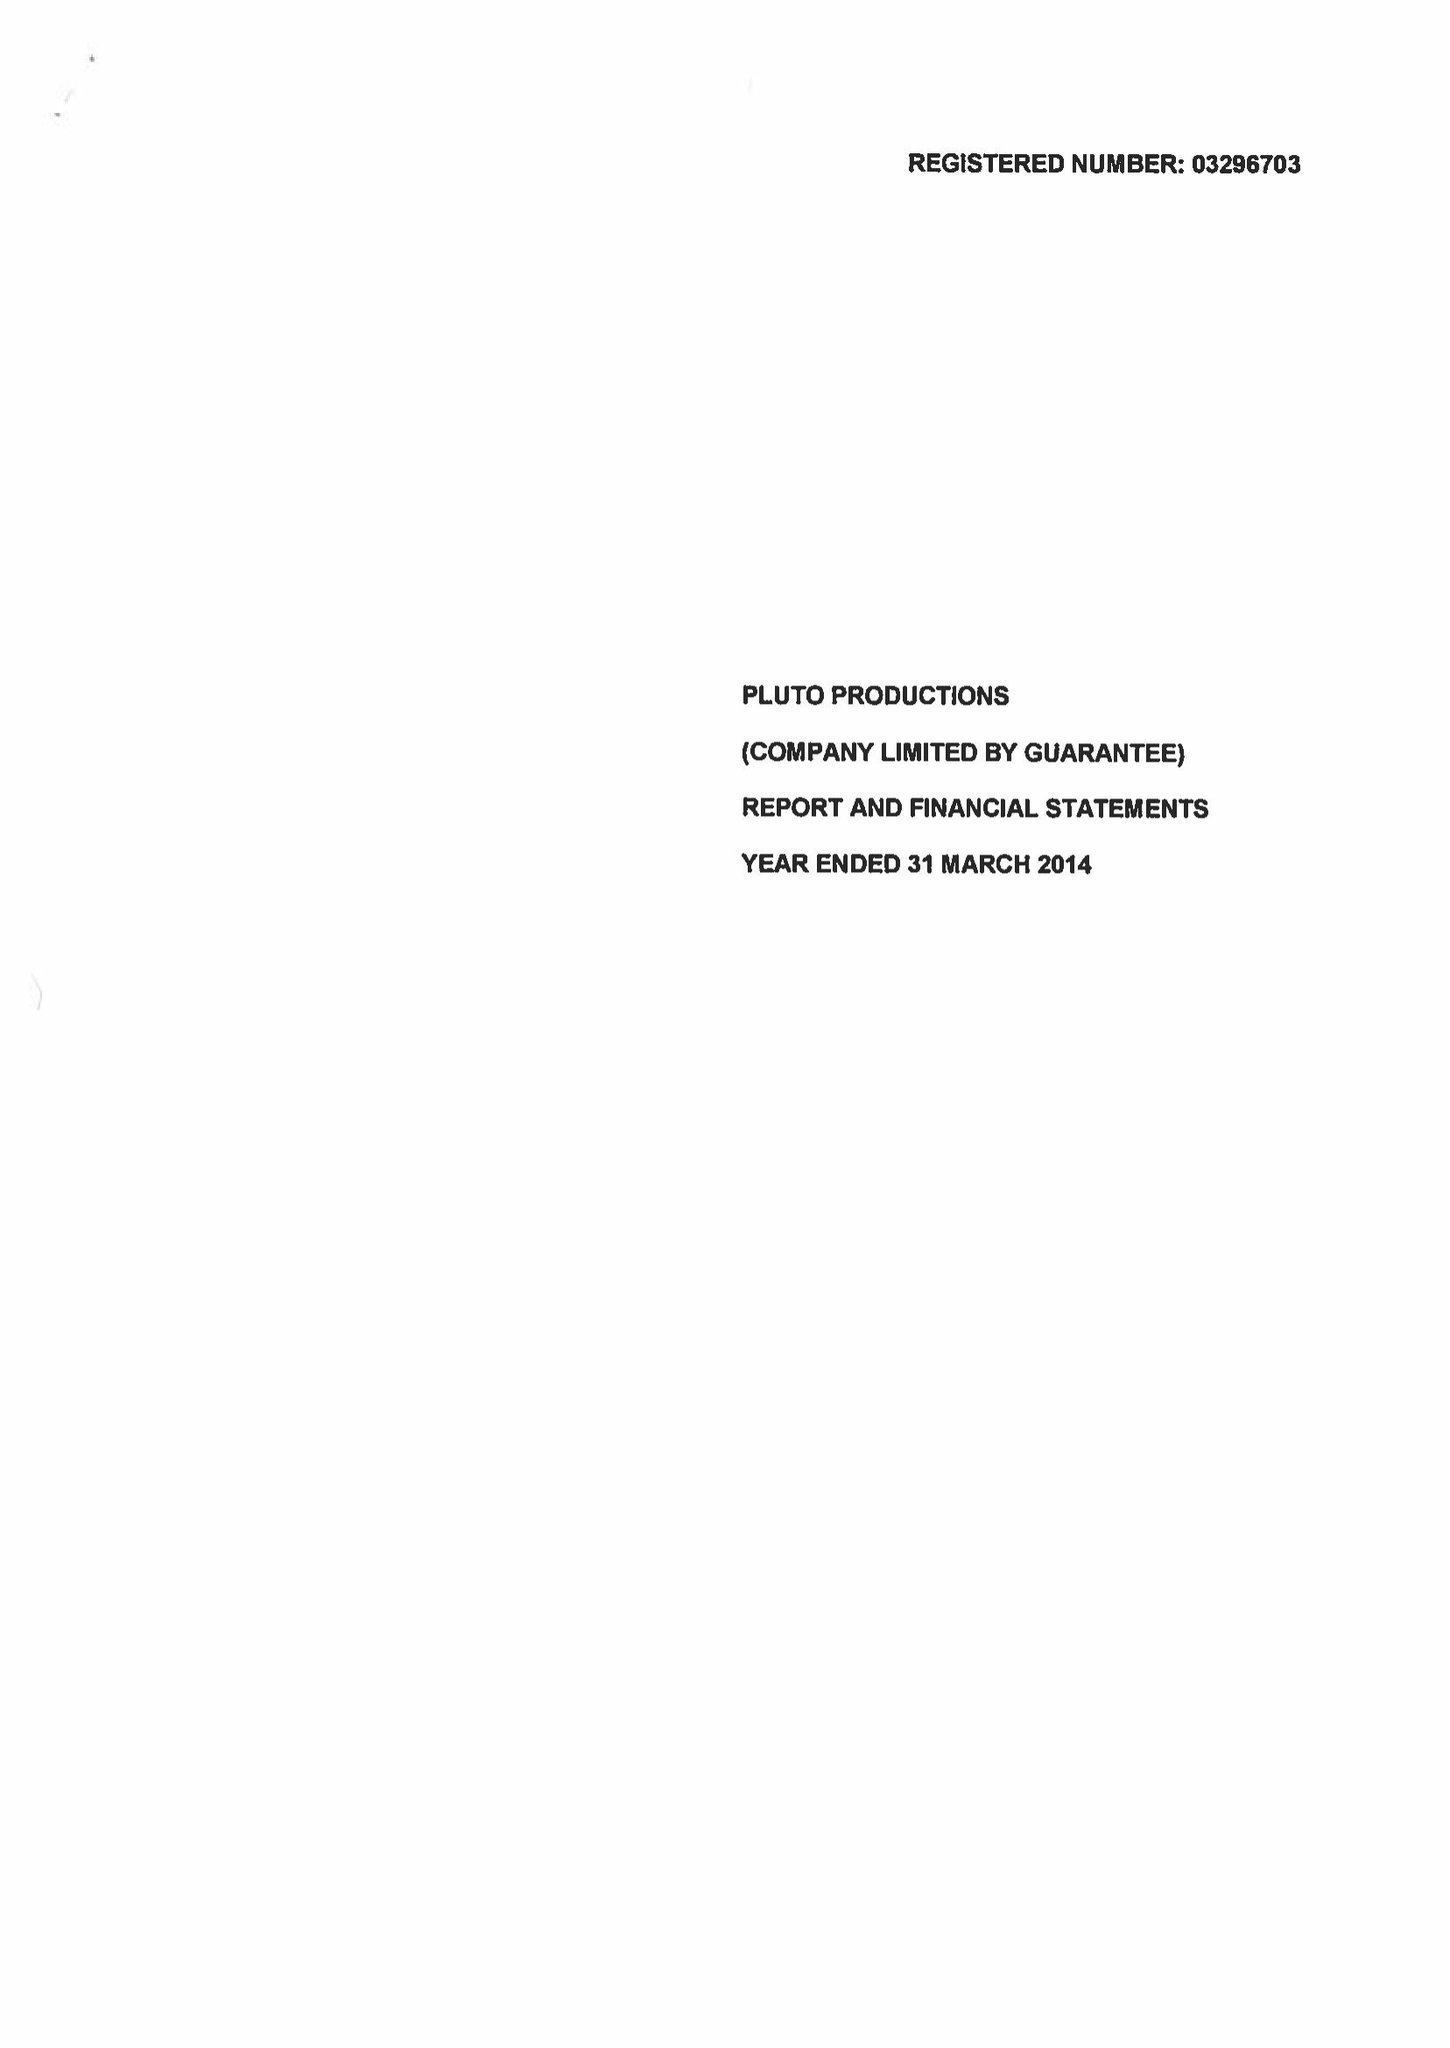What is the value for the address__postcode?
Answer the question using a single word or phrase. LS7 2AL 